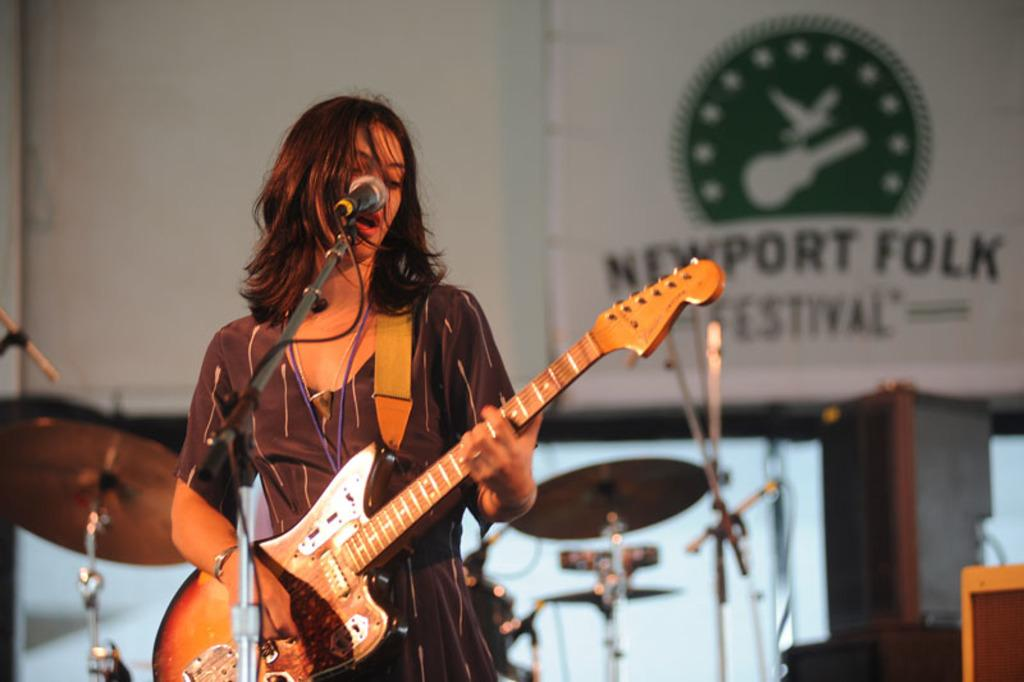What is the woman in the image doing? The woman is standing, playing a guitar, singing, and using a microphone. What instrument is the woman playing in the image? The woman is playing a guitar in the image. What is the woman using to amplify her voice in the image? The woman is using a microphone in the image. What can be seen in the background of the image? There is a hoarding visible in the background of the image. What type of feather is the woman using to play the guitar in the image? There is no feather present in the image; the woman is playing a guitar with her hands. 